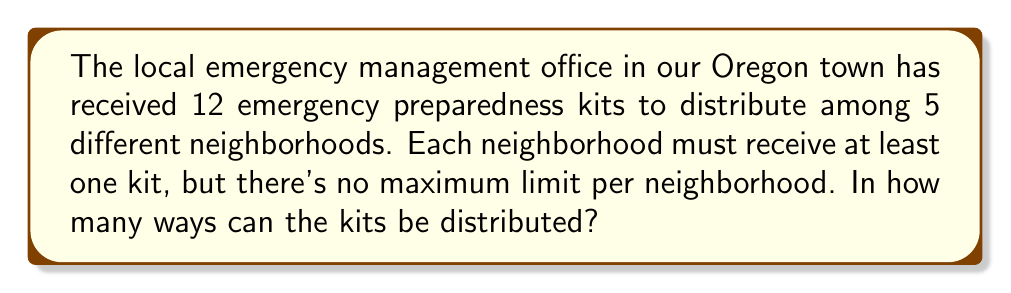Can you answer this question? Let's approach this step-by-step:

1) This is a problem of distributing identical objects (kits) into distinct containers (neighborhoods) with restrictions.

2) We can use the concept of "Stars and Bars" to solve this. The formula for this scenario is:

   $${n-1 \choose k-1}$$

   Where $n$ is the number of identical objects plus the number of containers, and $k$ is the number of containers.

3) In this case:
   - We have 12 kits and 5 neighborhoods
   - Each neighborhood must get at least one kit, so we first give one kit to each neighborhood
   - This leaves us with 7 kits to distribute (12 - 5 = 7)

4) Now we can apply the formula:
   - $n = 7 + 5 = 12$ (remaining kits plus neighborhoods)
   - $k = 5$ (neighborhoods)

5) Plugging into our formula:

   $${12-1 \choose 5-1} = {11 \choose 4}$$

6) We can calculate this:

   $${11 \choose 4} = \frac{11!}{4!(11-4)!} = \frac{11!}{4!7!} = 330$$

Therefore, there are 330 ways to distribute the kits.
Answer: 330 